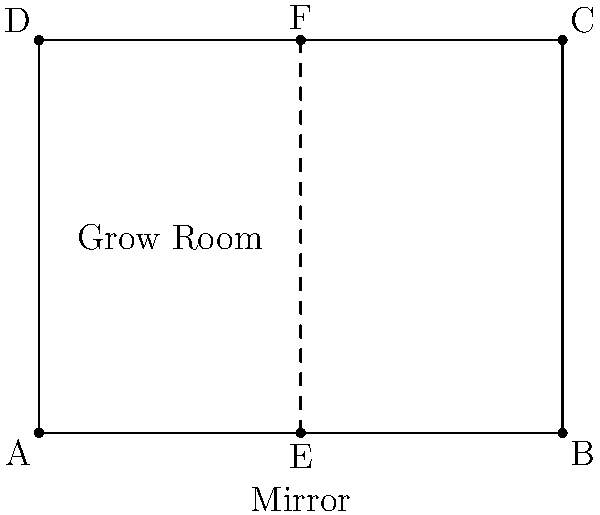In a rectangular grow room with dimensions 4x3, a mirrored wall is installed along the line of symmetry. How many unique arrangements of cannabis plants are possible if you place 3 plants in the room, assuming plants on the mirror line are counted only once? To solve this problem, we need to consider the reflective symmetry created by the mirrored wall:

1. The grow room is divided into two equal halves by the mirror.
2. Any arrangement on one side will be reflected on the other side.
3. Plants placed directly on the mirror line are not reflected and count only once.

Let's break down the possible arrangements:

1. All plants on one side of the mirror:
   - This creates 3 unique arrangements (as the other side will be a reflection).

2. Two plants on one side, one on the mirror:
   - This creates $\binom{3}{2} = 3$ unique arrangements.

3. One plant on one side, two on the mirror:
   - This creates $\binom{3}{1} = 3$ unique arrangements.

4. All three plants on the mirror:
   - This creates only 1 unique arrangement.

The total number of unique arrangements is the sum of all these possibilities:

$$ 3 + 3 + 3 + 1 = 10 $$

Therefore, there are 10 unique arrangements possible.
Answer: 10 unique arrangements 